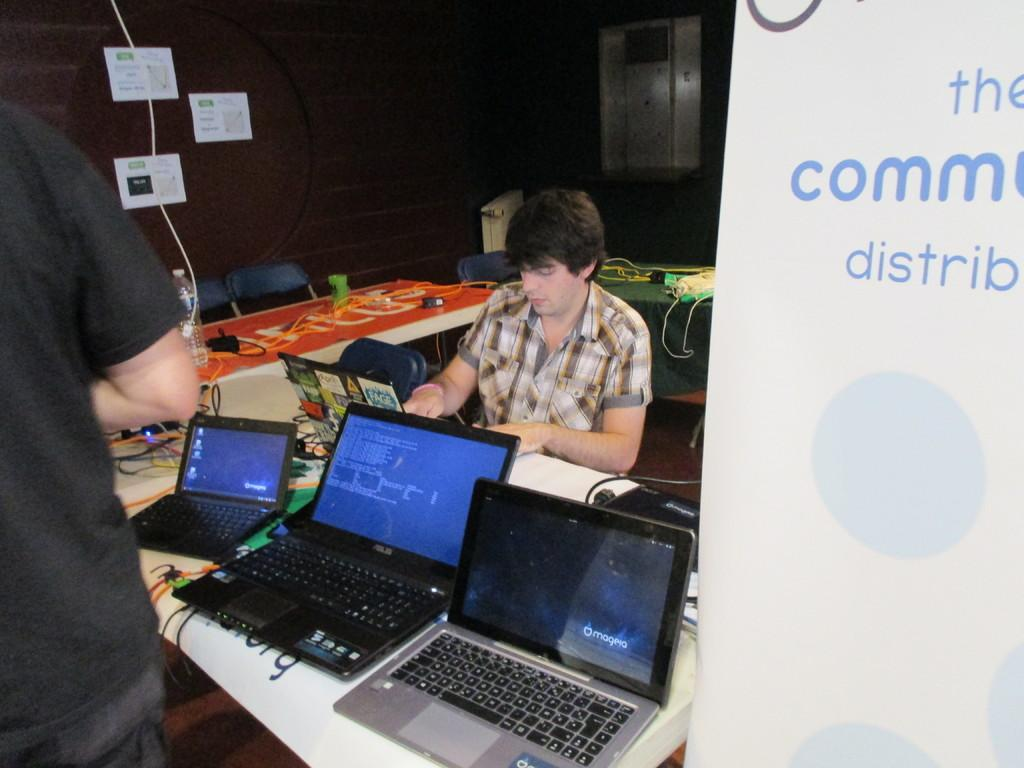Provide a one-sentence caption for the provided image. Man sitting with laptops and on the right side the word the comm distrib. 